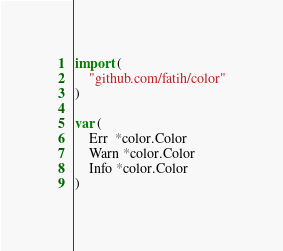<code> <loc_0><loc_0><loc_500><loc_500><_Go_>import (
	"github.com/fatih/color"
)

var (
	Err  *color.Color
	Warn *color.Color
	Info *color.Color
)
</code> 